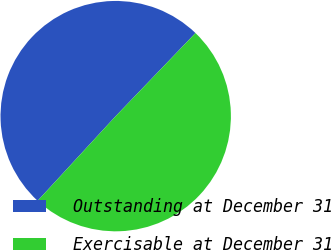Convert chart. <chart><loc_0><loc_0><loc_500><loc_500><pie_chart><fcel>Outstanding at December 31<fcel>Exercisable at December 31<nl><fcel>50.32%<fcel>49.68%<nl></chart> 